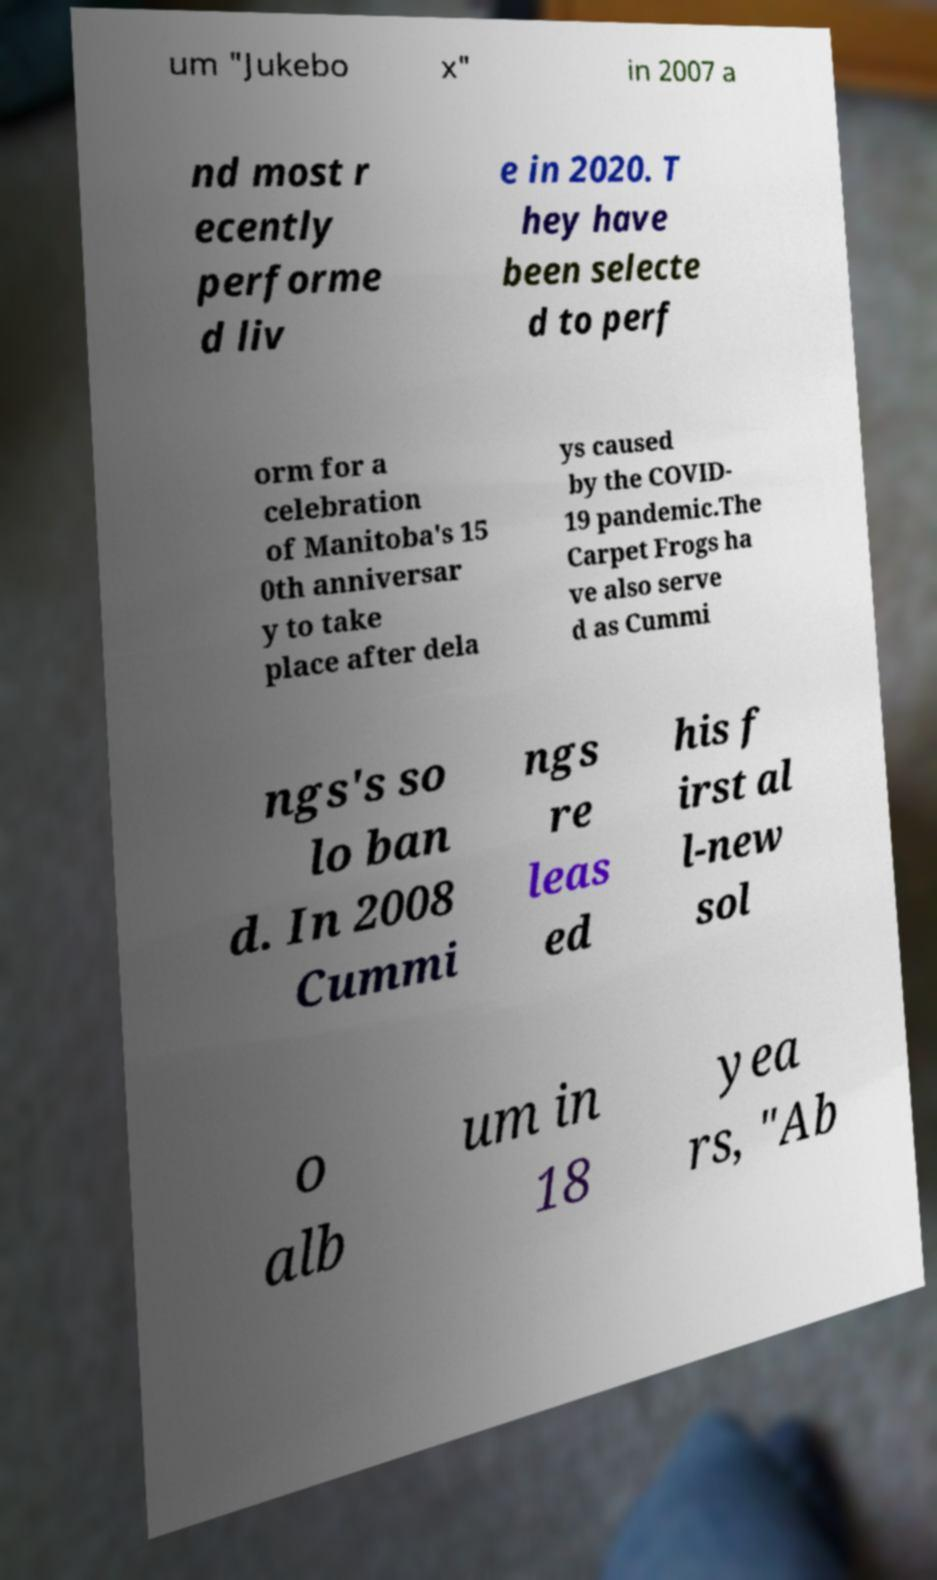Please read and relay the text visible in this image. What does it say? um "Jukebo x" in 2007 a nd most r ecently performe d liv e in 2020. T hey have been selecte d to perf orm for a celebration of Manitoba's 15 0th anniversar y to take place after dela ys caused by the COVID- 19 pandemic.The Carpet Frogs ha ve also serve d as Cummi ngs's so lo ban d. In 2008 Cummi ngs re leas ed his f irst al l-new sol o alb um in 18 yea rs, "Ab 